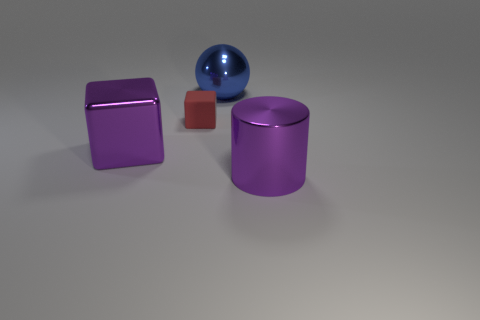What is the material of the red thing in front of the large thing that is behind the big purple metal object behind the shiny cylinder?
Provide a short and direct response. Rubber. How many other things are there of the same size as the cylinder?
Keep it short and to the point. 2. The sphere is what color?
Your answer should be very brief. Blue. How many metallic things are either big blue objects or big purple blocks?
Ensure brevity in your answer.  2. Is there anything else that is the same material as the tiny thing?
Provide a short and direct response. No. What size is the purple object behind the purple thing right of the big purple thing left of the tiny object?
Ensure brevity in your answer.  Large. There is a shiny object that is in front of the blue ball and on the left side of the large purple cylinder; how big is it?
Ensure brevity in your answer.  Large. Do the thing that is in front of the purple cube and the big object on the left side of the blue metallic sphere have the same color?
Ensure brevity in your answer.  Yes. What number of large blue spheres are behind the large purple metallic block?
Make the answer very short. 1. Is there a big sphere that is in front of the block that is behind the purple thing that is behind the large purple cylinder?
Your response must be concise. No. 